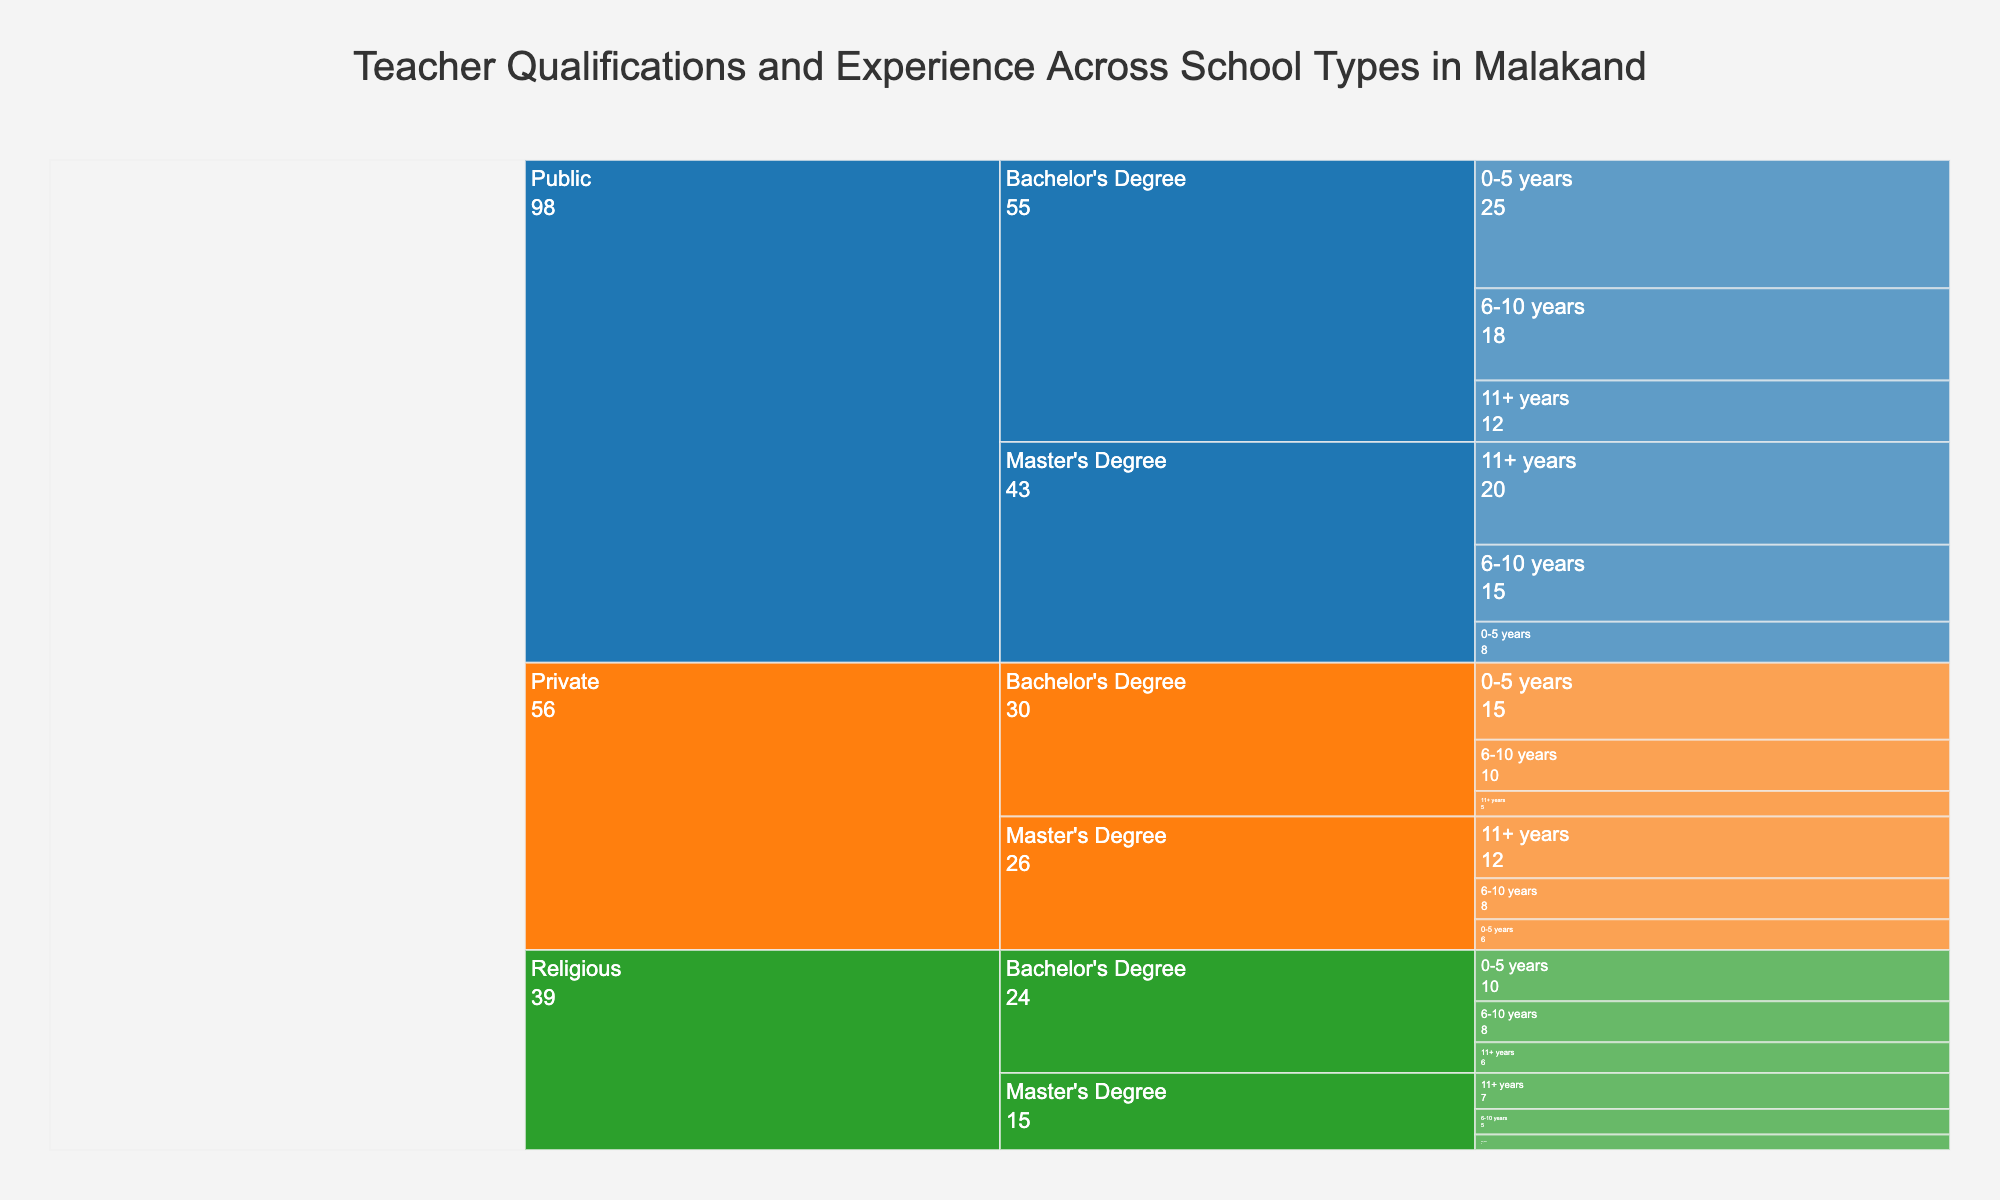How many teachers in public schools have Master's Degrees with 11+ years of experience? Look at the Public schools section, then navigate to Master's Degree under Qualification, and check the count for 11+ years of Experience.
Answer: 20 Which school type has the highest number of teachers with Bachelor's Degrees and 0-5 years of experience? Compare the counts of teachers with Bachelor's Degrees and 0-5 years of experience among Public, Private, and Religious schools. Public has 25, Private has 15, and Religious has 10.
Answer: Public What is the total number of teachers with Master’s Degrees in all school types? Sum the count of teachers with Master’s Degrees across all school types and experience levels. In Public: 8+15+20, in Private: 6+8+12, in Religious: 3+5+7. Add them together.
Answer: 109 Do Private schools have more teachers with 0-5 years of experience or 6-10 years of experience? Focus on Private schools and compare the counts of teachers with 0-5 years and 6-10 years of experience. 0-5 years: 15+6, 6-10 years: 10+8.
Answer: 0-5 years What is the difference between the number of Public and Private school teachers with 11+ years of experience and a Master’s Degree? Subtract the count of Private school teachers with 11+ years of experience and a Master’s Degree from the count of Public school teachers in the same category. Public has 20, Private has 12. 20-12.
Answer: 8 Which school type has the least number of teachers with Master's Degrees and 6-10 years of experience? Compare the counts among Public, Private, and Religious schools for teachers with Master's Degrees and 6-10 years of experience. Public has 15, Private has 8, Religious has 5.
Answer: Religious How many teachers in total are in Religious schools? Sum the counts of all teachers in Religious schools considering all qualifications and years of experience. Bachelor's Degree: 10+8+6, Master's Degree: 3+5+7. Add them together.
Answer: 39 Is the number of teachers with Bachelor's Degrees and 6-10 years of experience greater in Public or Religious schools? Compare the number of teachers with Bachelor's Degrees and 6-10 years of experience between Public and Religious schools. Public has 18, Religious has 8.
Answer: Public What is the total number of teachers with 0-5 years of experience across all school types? Add the counts of teachers with 0-5 years of experience across Public, Private, and Religious schools for both qualifications. Public: 25+8, Private: 15+6, Religious: 10+3.
Answer: 67 